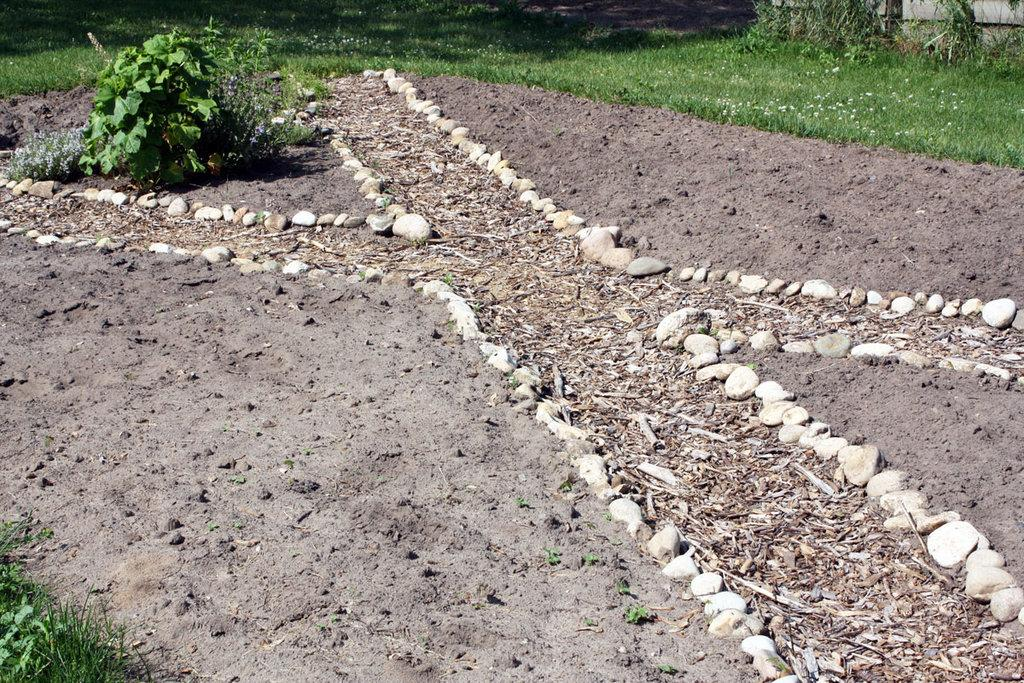What type of material covers the ground in the image? There are stones and wooden sticks on the ground in the image. What can be seen in the background of the image? There are plants, grass, and some unspecified objects in the background of the image. How many toy spiders are crawling on the wooden sticks in the image? There are no toy spiders present in the image. What type of haircut does the person in the image have? There is no person present in the image, so it is not possible to determine their haircut. 